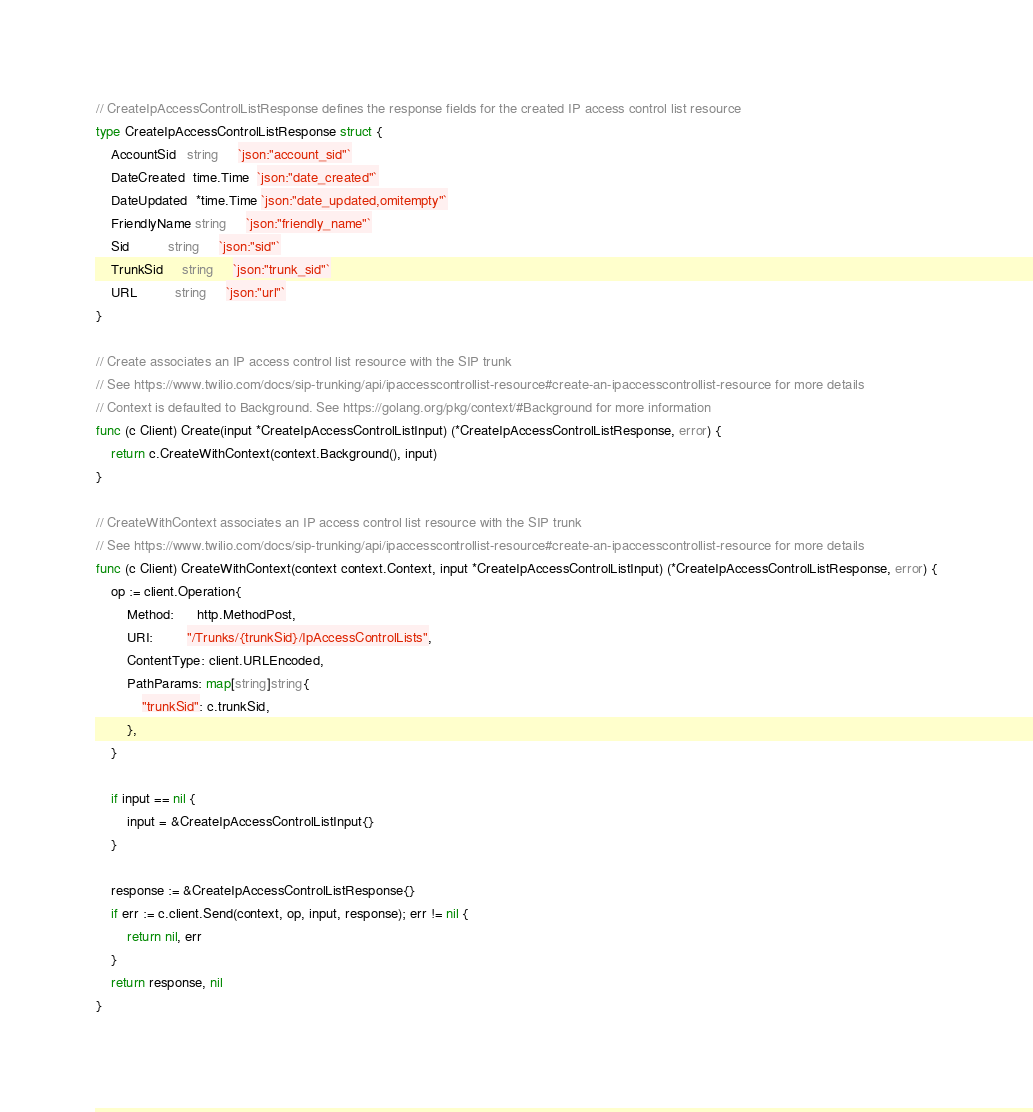Convert code to text. <code><loc_0><loc_0><loc_500><loc_500><_Go_>
// CreateIpAccessControlListResponse defines the response fields for the created IP access control list resource
type CreateIpAccessControlListResponse struct {
	AccountSid   string     `json:"account_sid"`
	DateCreated  time.Time  `json:"date_created"`
	DateUpdated  *time.Time `json:"date_updated,omitempty"`
	FriendlyName string     `json:"friendly_name"`
	Sid          string     `json:"sid"`
	TrunkSid     string     `json:"trunk_sid"`
	URL          string     `json:"url"`
}

// Create associates an IP access control list resource with the SIP trunk
// See https://www.twilio.com/docs/sip-trunking/api/ipaccesscontrollist-resource#create-an-ipaccesscontrollist-resource for more details
// Context is defaulted to Background. See https://golang.org/pkg/context/#Background for more information
func (c Client) Create(input *CreateIpAccessControlListInput) (*CreateIpAccessControlListResponse, error) {
	return c.CreateWithContext(context.Background(), input)
}

// CreateWithContext associates an IP access control list resource with the SIP trunk
// See https://www.twilio.com/docs/sip-trunking/api/ipaccesscontrollist-resource#create-an-ipaccesscontrollist-resource for more details
func (c Client) CreateWithContext(context context.Context, input *CreateIpAccessControlListInput) (*CreateIpAccessControlListResponse, error) {
	op := client.Operation{
		Method:      http.MethodPost,
		URI:         "/Trunks/{trunkSid}/IpAccessControlLists",
		ContentType: client.URLEncoded,
		PathParams: map[string]string{
			"trunkSid": c.trunkSid,
		},
	}

	if input == nil {
		input = &CreateIpAccessControlListInput{}
	}

	response := &CreateIpAccessControlListResponse{}
	if err := c.client.Send(context, op, input, response); err != nil {
		return nil, err
	}
	return response, nil
}
</code> 